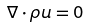Convert formula to latex. <formula><loc_0><loc_0><loc_500><loc_500>\nabla \cdot \rho { u } = 0</formula> 